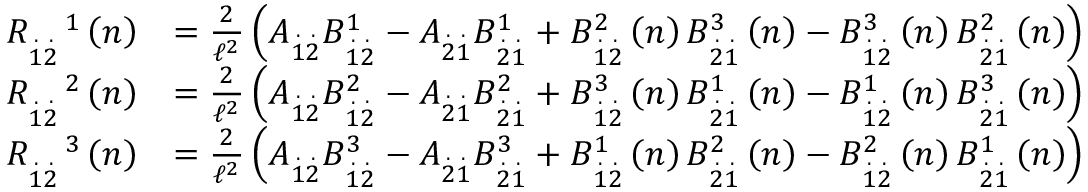<formula> <loc_0><loc_0><loc_500><loc_500>\begin{array} { r l } { R _ { \overset { . } { 1 } \overset { . } { 2 } } ^ { \quad 1 } \left ( n \right ) } & { = \frac { 2 } { \mathcal { \ell } ^ { 2 } } \left ( A _ { \overset { . } { 1 } \overset { . } { 2 } } B _ { \overset { . } { 1 } \overset { . } { 2 } } ^ { 1 } - A _ { \overset { . } { 2 } \overset { . } { 1 } } B _ { \overset { . } { 2 } \overset { . } { 1 } } ^ { 1 } + B _ { \overset { . } { 1 } \overset { . } { 2 } } ^ { 2 } \left ( n \right ) B _ { \overset { . } { 2 } \overset { . } { 1 } } ^ { 3 } \left ( n \right ) - B _ { \overset { . } { 1 } \overset { . } { 2 } } ^ { 3 } \left ( n \right ) B _ { \overset { . } { 2 } \overset { . } { 1 } } ^ { 2 } \left ( n \right ) \right ) } \\ { R _ { \overset { . } { 1 } \overset { . } { 2 } } ^ { \quad 2 } \left ( n \right ) } & { = \frac { 2 } { \mathcal { \ell } ^ { 2 } } \left ( A _ { \overset { . } { 1 } \overset { . } { 2 } } B _ { \overset { . } { 1 } \overset { . } { 2 } } ^ { 2 } - A _ { \overset { . } { 2 } \overset { . } { 1 } } B _ { \overset { . } { 2 } \overset { . } { 1 } } ^ { 2 } + B _ { \overset { . } { 1 } \overset { . } { 2 } } ^ { 3 } \left ( n \right ) B _ { \overset { . } { 2 } \overset { . } { 1 } } ^ { 1 } \left ( n \right ) - B _ { \overset { . } { 1 } \overset { . } { 2 } } ^ { 1 } \left ( n \right ) B _ { \overset { . } { 2 } \overset { . } { 1 } } ^ { 3 } \left ( n \right ) \right ) } \\ { R _ { \overset { . } { 1 } \overset { . } { 2 } } ^ { \quad 3 } \left ( n \right ) } & { = \frac { 2 } { \mathcal { \ell } ^ { 2 } } \left ( A _ { \overset { . } { 1 } \overset { . } { 2 } } B _ { \overset { . } { 1 } \overset { . } { 2 } } ^ { 3 } - A _ { \overset { . } { 2 } \overset { . } { 1 } } B _ { \overset { . } { 2 } \overset { . } { 1 } } ^ { 3 } + B _ { \overset { . } { 1 } \overset { . } { 2 } } ^ { 1 } \left ( n \right ) B _ { \overset { . } { 2 } \overset { . } { 1 } } ^ { 2 } \left ( n \right ) - B _ { \overset { . } { 1 } \overset { . } { 2 } } ^ { 2 } \left ( n \right ) B _ { \overset { . } { 2 } \overset { . } { 1 } } ^ { 1 } \left ( n \right ) \right ) } \end{array}</formula> 